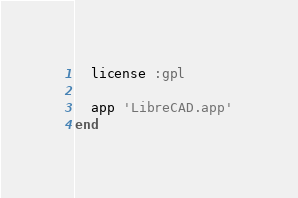<code> <loc_0><loc_0><loc_500><loc_500><_Ruby_>  license :gpl

  app 'LibreCAD.app'
end
</code> 